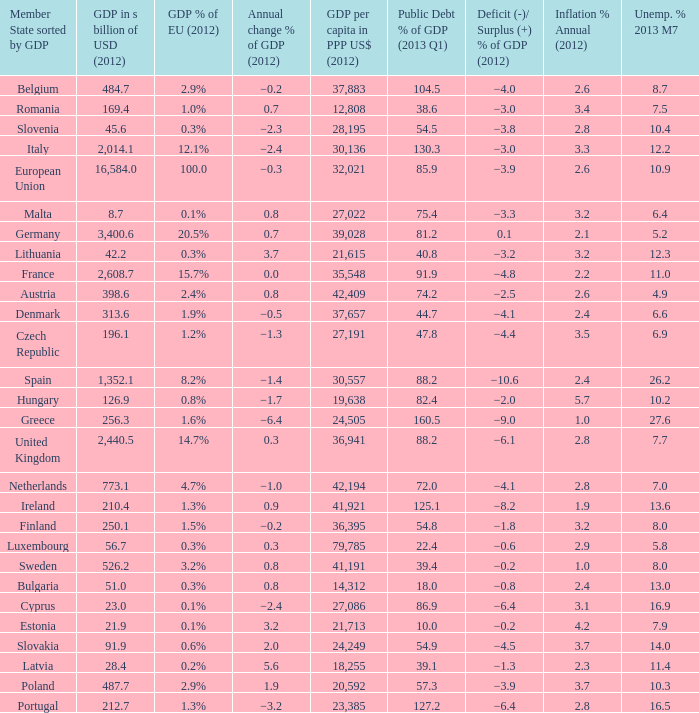What is the GDP % of EU in 2012 of the country with a GDP in billions of USD in 2012 of 256.3? 1.6%. 